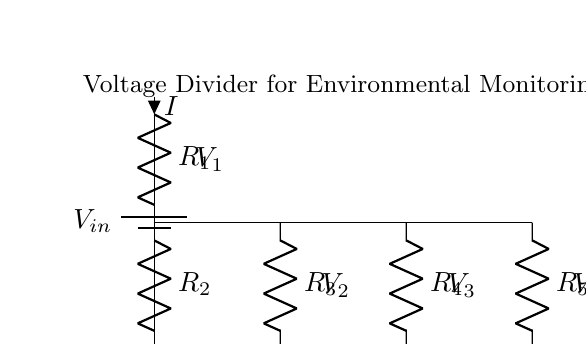What type of circuit is depicted? The circuit is a voltage divider, which is used to reduce a higher voltage to a lower voltage based on the resistor values. It consists of multiple resistors connected in series.
Answer: Voltage divider How many resistors are in the circuit? There are five resistors labeled as R1, R2, R3, R4, and R5 in the circuit.
Answer: Five What is the source voltage labeled in the diagram? The source voltage is marked as Vin, representing the input voltage supplied to the voltage divider. The exact numeric value isn't provided in the question but is depicted as a battery symbol.
Answer: Vin What is the voltage level across R2? The voltage across R2 can be indicated as V2, which is taken from the junction of R1 and R2 to the ground based on the voltage divider principle.
Answer: V2 What role do the resistors R3, R4, and R5 serve? R3, R4, and R5 serve as additional voltage dividers to produce lower voltages for the classroom sensors, allowing for distribution of power to multiple sensors from the same input voltage.
Answer: Power distribution When calculating the output voltage for each resistor, what do you need to know? To calculate the output voltage for each resistor in the circuit, you need to know the input voltage Vin and the values of the resistors R1, R2, R3, R4, and R5 to apply the voltage divider formula.
Answer: Resistor values and Vin 